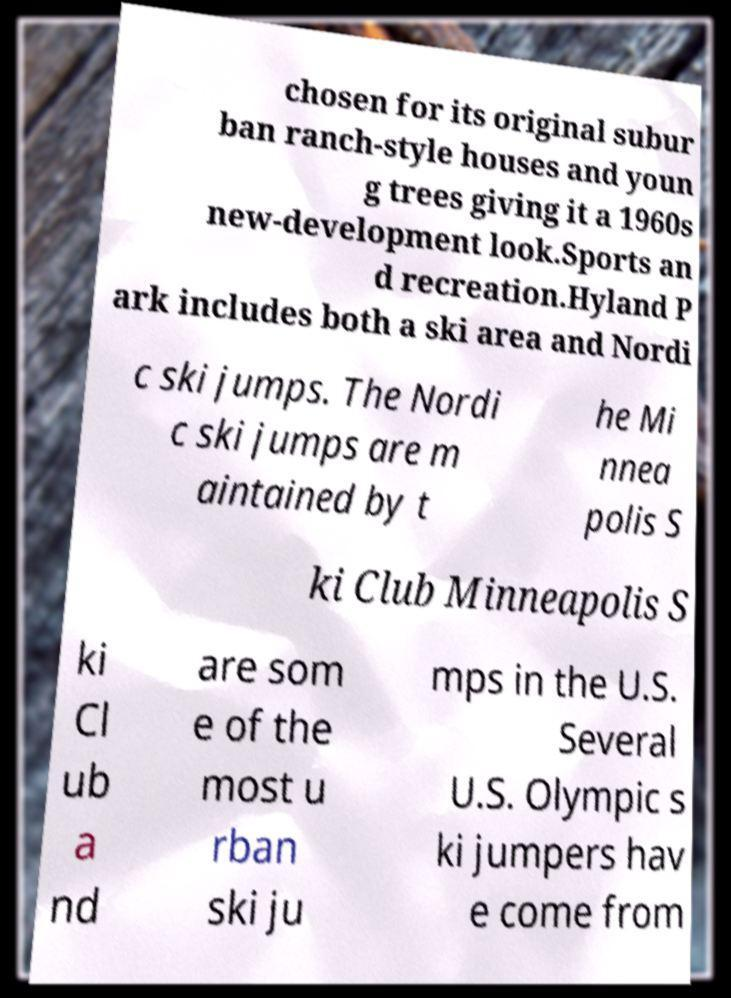What messages or text are displayed in this image? I need them in a readable, typed format. chosen for its original subur ban ranch-style houses and youn g trees giving it a 1960s new-development look.Sports an d recreation.Hyland P ark includes both a ski area and Nordi c ski jumps. The Nordi c ski jumps are m aintained by t he Mi nnea polis S ki Club Minneapolis S ki Cl ub a nd are som e of the most u rban ski ju mps in the U.S. Several U.S. Olympic s ki jumpers hav e come from 